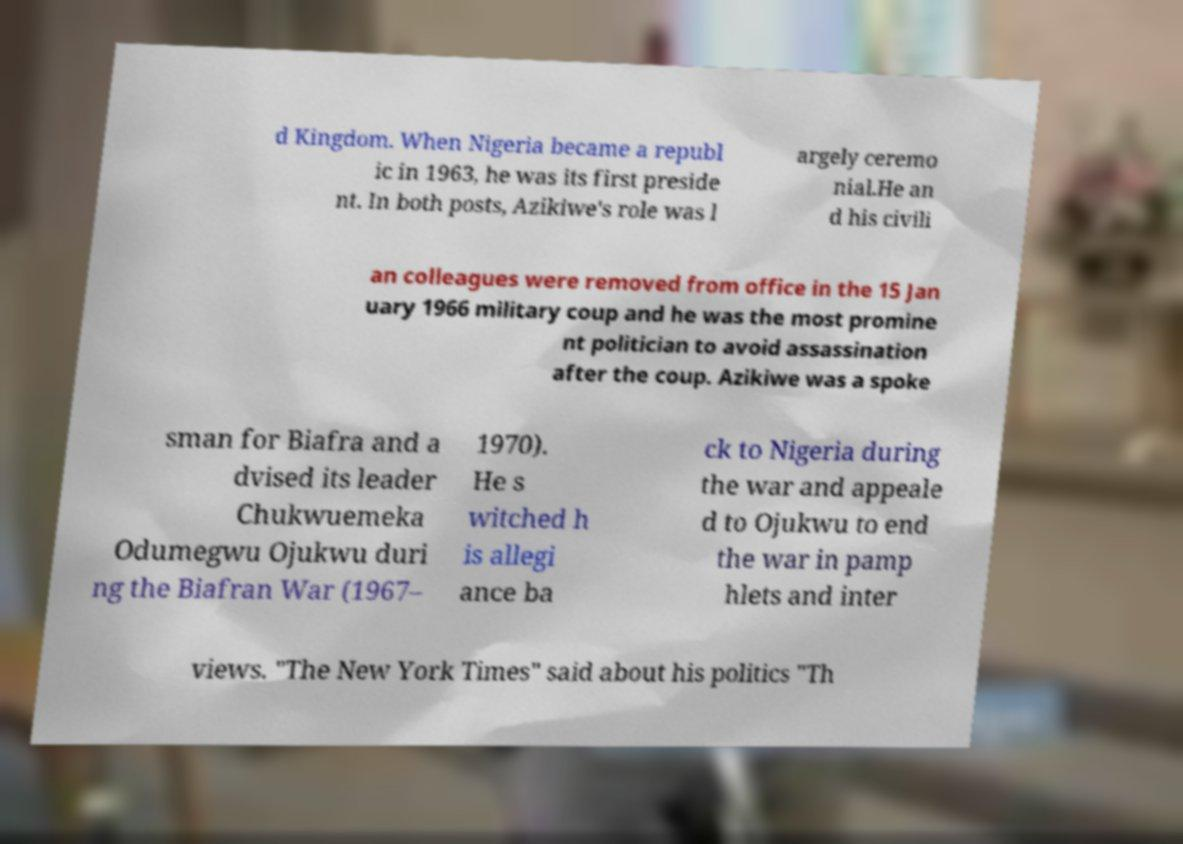Could you extract and type out the text from this image? d Kingdom. When Nigeria became a republ ic in 1963, he was its first preside nt. In both posts, Azikiwe's role was l argely ceremo nial.He an d his civili an colleagues were removed from office in the 15 Jan uary 1966 military coup and he was the most promine nt politician to avoid assassination after the coup. Azikiwe was a spoke sman for Biafra and a dvised its leader Chukwuemeka Odumegwu Ojukwu duri ng the Biafran War (1967– 1970). He s witched h is allegi ance ba ck to Nigeria during the war and appeale d to Ojukwu to end the war in pamp hlets and inter views. "The New York Times" said about his politics "Th 